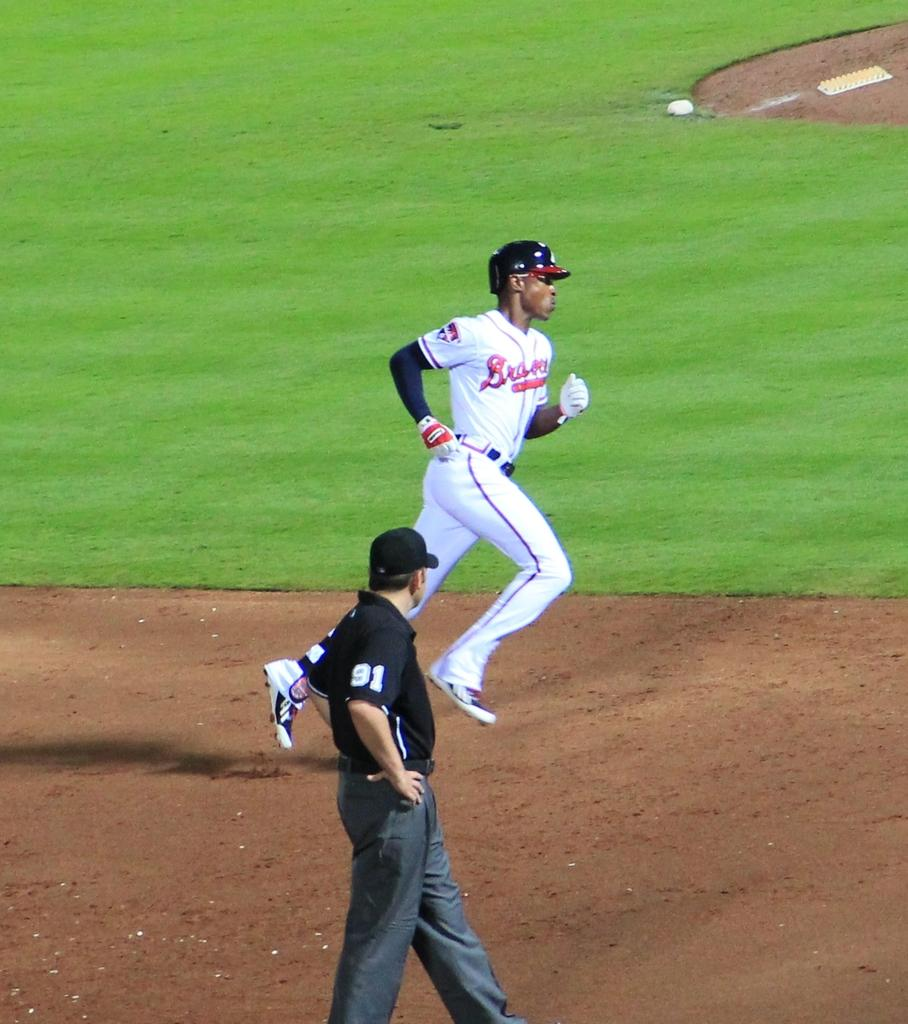<image>
Relay a brief, clear account of the picture shown. A player from the baseball team called the Braves 